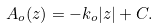<formula> <loc_0><loc_0><loc_500><loc_500>A _ { o } ( z ) = - k _ { o } | z | + C .</formula> 